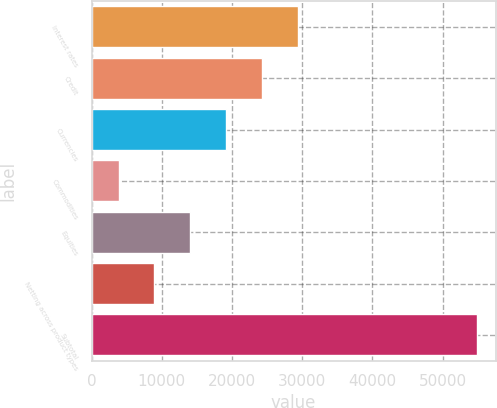Convert chart to OTSL. <chart><loc_0><loc_0><loc_500><loc_500><bar_chart><fcel>Interest rates<fcel>Credit<fcel>Currencies<fcel>Commodities<fcel>Equities<fcel>Netting across product types<fcel>Subtotal<nl><fcel>29345.5<fcel>24248.8<fcel>19152.1<fcel>3862<fcel>14055.4<fcel>8958.7<fcel>54829<nl></chart> 